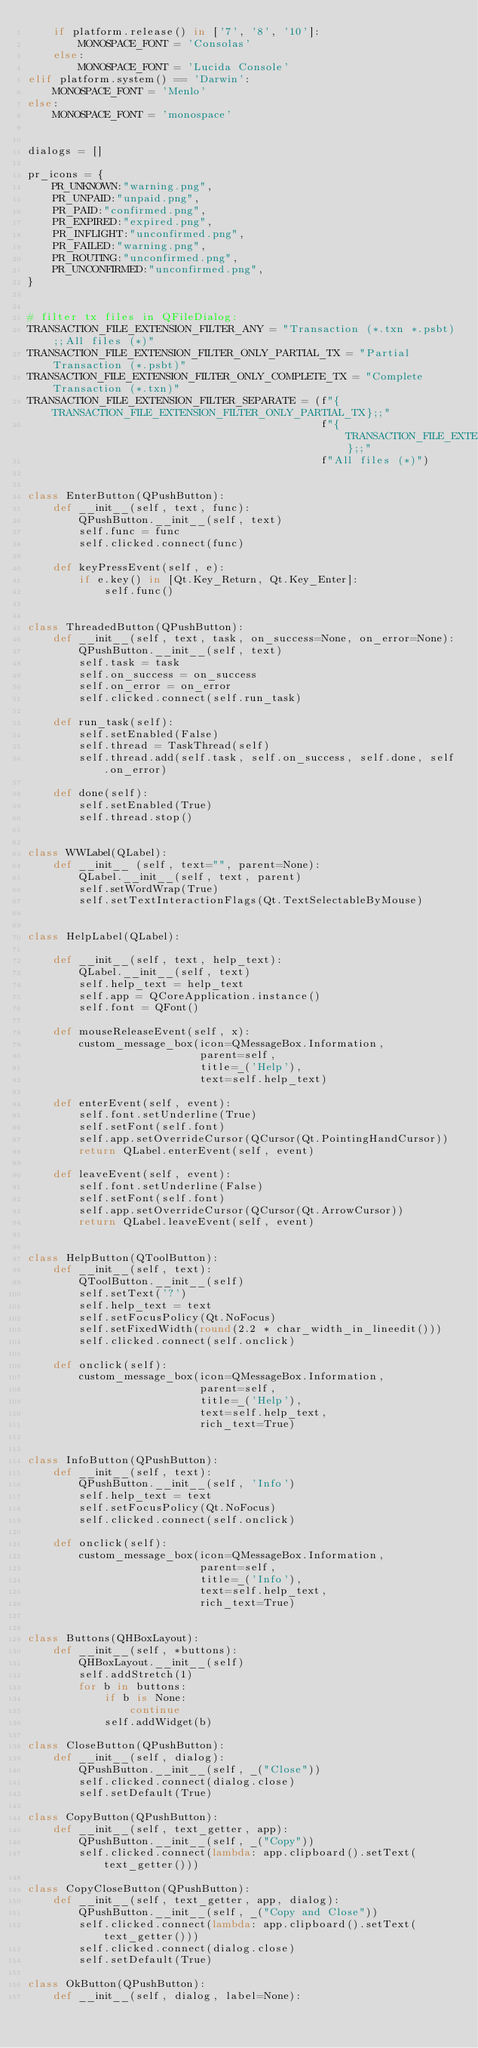<code> <loc_0><loc_0><loc_500><loc_500><_Python_>    if platform.release() in ['7', '8', '10']:
        MONOSPACE_FONT = 'Consolas'
    else:
        MONOSPACE_FONT = 'Lucida Console'
elif platform.system() == 'Darwin':
    MONOSPACE_FONT = 'Menlo'
else:
    MONOSPACE_FONT = 'monospace'


dialogs = []

pr_icons = {
    PR_UNKNOWN:"warning.png",
    PR_UNPAID:"unpaid.png",
    PR_PAID:"confirmed.png",
    PR_EXPIRED:"expired.png",
    PR_INFLIGHT:"unconfirmed.png",
    PR_FAILED:"warning.png",
    PR_ROUTING:"unconfirmed.png",
    PR_UNCONFIRMED:"unconfirmed.png",
}


# filter tx files in QFileDialog:
TRANSACTION_FILE_EXTENSION_FILTER_ANY = "Transaction (*.txn *.psbt);;All files (*)"
TRANSACTION_FILE_EXTENSION_FILTER_ONLY_PARTIAL_TX = "Partial Transaction (*.psbt)"
TRANSACTION_FILE_EXTENSION_FILTER_ONLY_COMPLETE_TX = "Complete Transaction (*.txn)"
TRANSACTION_FILE_EXTENSION_FILTER_SEPARATE = (f"{TRANSACTION_FILE_EXTENSION_FILTER_ONLY_PARTIAL_TX};;"
                                              f"{TRANSACTION_FILE_EXTENSION_FILTER_ONLY_COMPLETE_TX};;"
                                              f"All files (*)")


class EnterButton(QPushButton):
    def __init__(self, text, func):
        QPushButton.__init__(self, text)
        self.func = func
        self.clicked.connect(func)

    def keyPressEvent(self, e):
        if e.key() in [Qt.Key_Return, Qt.Key_Enter]:
            self.func()


class ThreadedButton(QPushButton):
    def __init__(self, text, task, on_success=None, on_error=None):
        QPushButton.__init__(self, text)
        self.task = task
        self.on_success = on_success
        self.on_error = on_error
        self.clicked.connect(self.run_task)

    def run_task(self):
        self.setEnabled(False)
        self.thread = TaskThread(self)
        self.thread.add(self.task, self.on_success, self.done, self.on_error)

    def done(self):
        self.setEnabled(True)
        self.thread.stop()


class WWLabel(QLabel):
    def __init__ (self, text="", parent=None):
        QLabel.__init__(self, text, parent)
        self.setWordWrap(True)
        self.setTextInteractionFlags(Qt.TextSelectableByMouse)


class HelpLabel(QLabel):

    def __init__(self, text, help_text):
        QLabel.__init__(self, text)
        self.help_text = help_text
        self.app = QCoreApplication.instance()
        self.font = QFont()

    def mouseReleaseEvent(self, x):
        custom_message_box(icon=QMessageBox.Information,
                           parent=self,
                           title=_('Help'),
                           text=self.help_text)

    def enterEvent(self, event):
        self.font.setUnderline(True)
        self.setFont(self.font)
        self.app.setOverrideCursor(QCursor(Qt.PointingHandCursor))
        return QLabel.enterEvent(self, event)

    def leaveEvent(self, event):
        self.font.setUnderline(False)
        self.setFont(self.font)
        self.app.setOverrideCursor(QCursor(Qt.ArrowCursor))
        return QLabel.leaveEvent(self, event)


class HelpButton(QToolButton):
    def __init__(self, text):
        QToolButton.__init__(self)
        self.setText('?')
        self.help_text = text
        self.setFocusPolicy(Qt.NoFocus)
        self.setFixedWidth(round(2.2 * char_width_in_lineedit()))
        self.clicked.connect(self.onclick)

    def onclick(self):
        custom_message_box(icon=QMessageBox.Information,
                           parent=self,
                           title=_('Help'),
                           text=self.help_text,
                           rich_text=True)


class InfoButton(QPushButton):
    def __init__(self, text):
        QPushButton.__init__(self, 'Info')
        self.help_text = text
        self.setFocusPolicy(Qt.NoFocus)
        self.clicked.connect(self.onclick)

    def onclick(self):
        custom_message_box(icon=QMessageBox.Information,
                           parent=self,
                           title=_('Info'),
                           text=self.help_text,
                           rich_text=True)


class Buttons(QHBoxLayout):
    def __init__(self, *buttons):
        QHBoxLayout.__init__(self)
        self.addStretch(1)
        for b in buttons:
            if b is None:
                continue
            self.addWidget(b)

class CloseButton(QPushButton):
    def __init__(self, dialog):
        QPushButton.__init__(self, _("Close"))
        self.clicked.connect(dialog.close)
        self.setDefault(True)

class CopyButton(QPushButton):
    def __init__(self, text_getter, app):
        QPushButton.__init__(self, _("Copy"))
        self.clicked.connect(lambda: app.clipboard().setText(text_getter()))

class CopyCloseButton(QPushButton):
    def __init__(self, text_getter, app, dialog):
        QPushButton.__init__(self, _("Copy and Close"))
        self.clicked.connect(lambda: app.clipboard().setText(text_getter()))
        self.clicked.connect(dialog.close)
        self.setDefault(True)

class OkButton(QPushButton):
    def __init__(self, dialog, label=None):</code> 